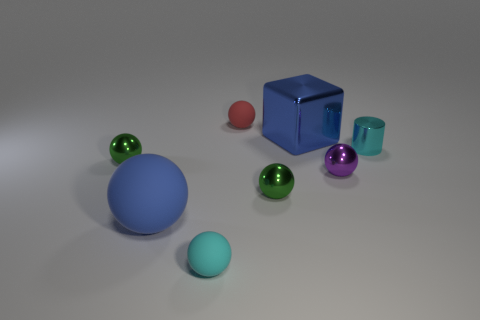What number of other objects are there of the same size as the blue metallic cube?
Make the answer very short. 1. The cylinder has what color?
Give a very brief answer. Cyan. Is the color of the metal ball to the left of the blue rubber thing the same as the tiny sphere that is behind the metal block?
Make the answer very short. No. The cyan ball has what size?
Keep it short and to the point. Small. There is a blue thing on the left side of the small red rubber thing; what is its size?
Ensure brevity in your answer.  Large. The matte thing that is behind the cyan ball and in front of the large blue block has what shape?
Keep it short and to the point. Sphere. What number of other things are there of the same shape as the tiny red object?
Offer a terse response. 5. There is a metal cylinder that is the same size as the red rubber ball; what is its color?
Offer a very short reply. Cyan. How many objects are either big blue metal blocks or big purple rubber spheres?
Ensure brevity in your answer.  1. There is a big block; are there any blue metallic blocks in front of it?
Your answer should be very brief. No. 